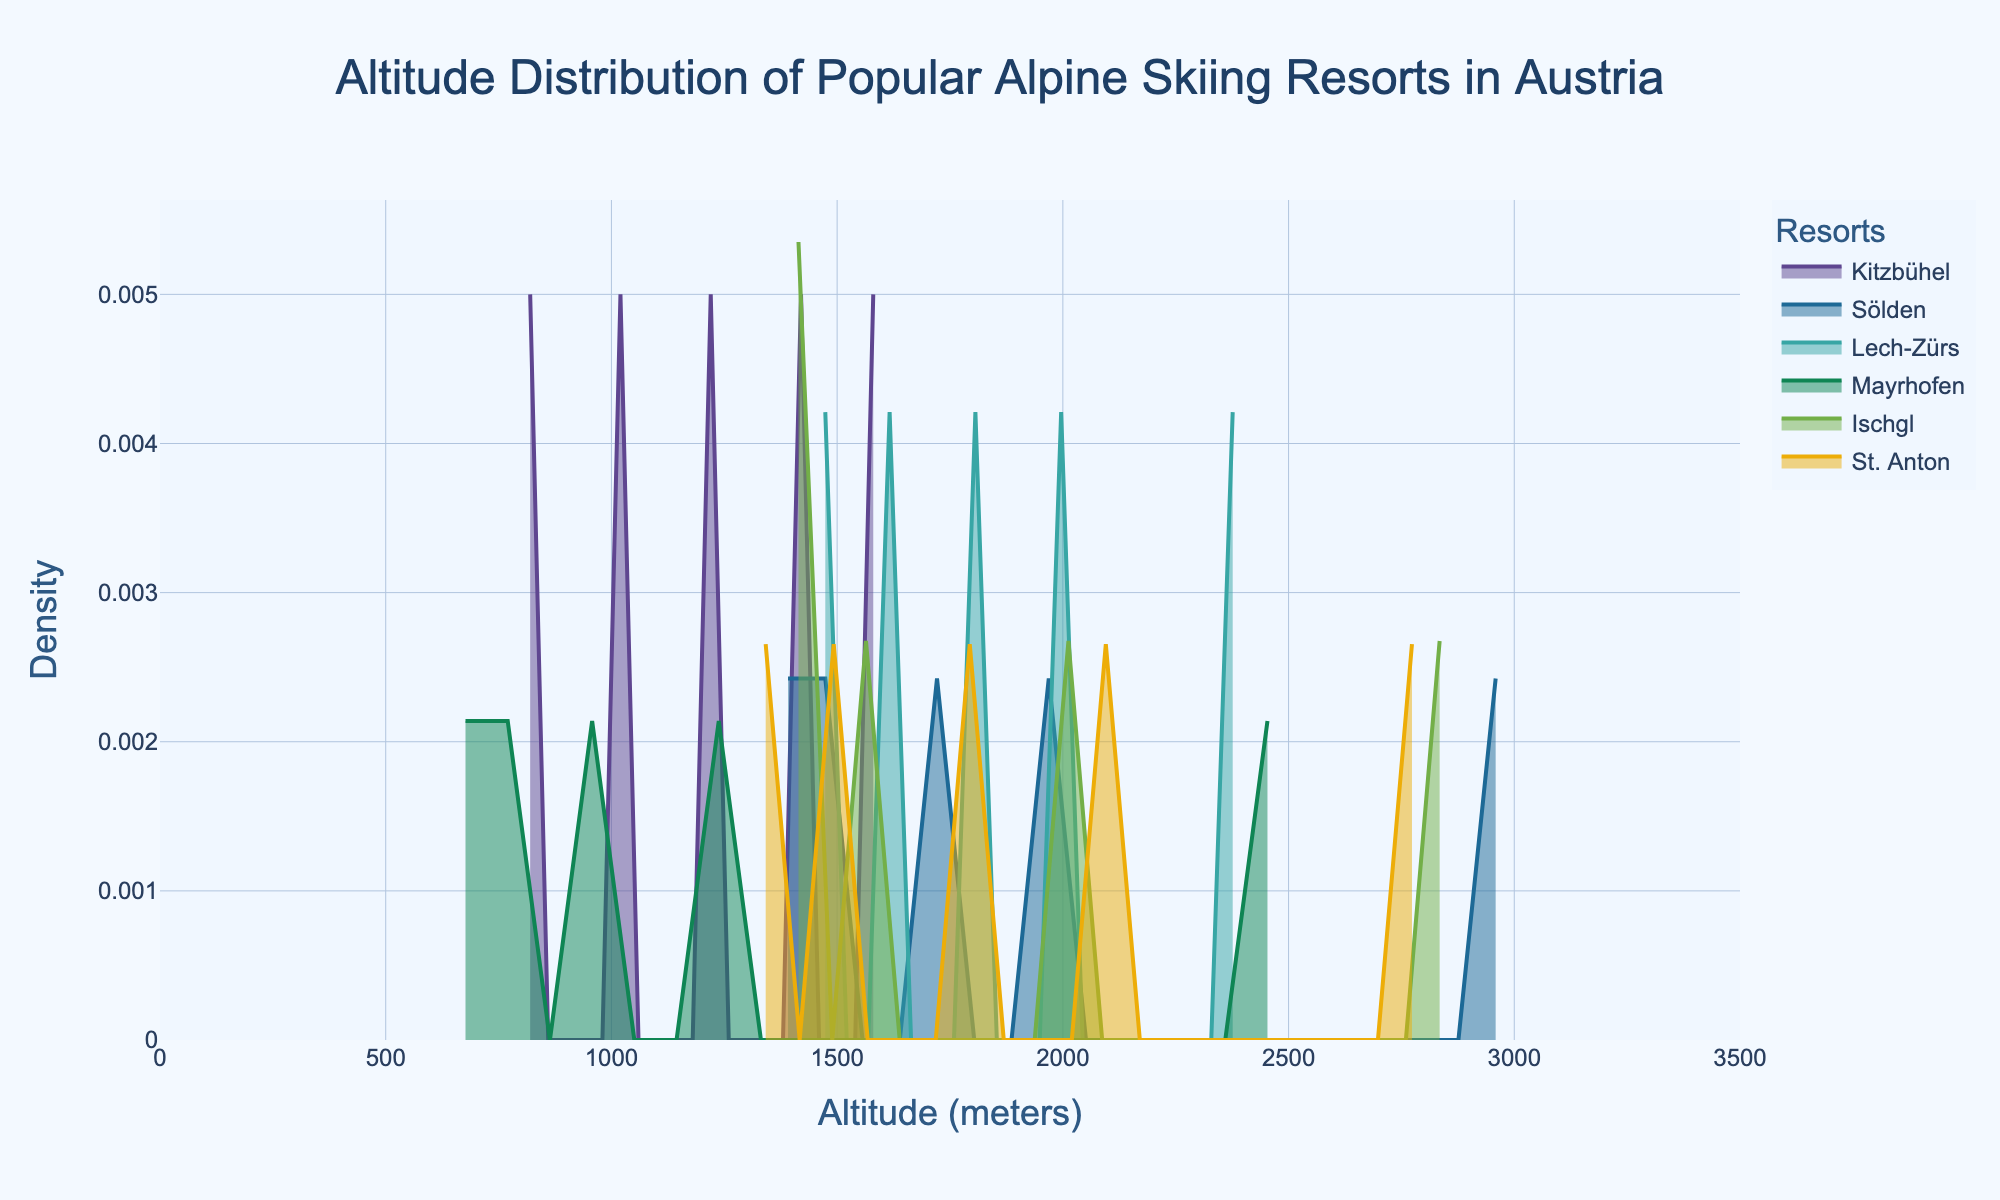What is the title of the figure? The title of the figure is found at the top and provides a summary of what the figure is about.
Answer: Altitude Distribution of Popular Alpine Skiing Resorts in Austria What is the average altitude for the Kitzbühel resort? To find the average, sum all the altitudes for Kitzbühel (800 + 1000 + 1200 + 1400 + 1600) and divide by the number of points (5). So, (800 + 1000 + 1200 + 1400 + 1600) / 5 = 6000 / 5.
Answer: 1200 Which resort has the highest peak density at high altitudes (above 2500 meters)? Review the left end of the curves on the plot, focusing on altitudes above 2500 meters. The highest density line in this region will indicate the resort with the highest peak density.
Answer: Sölden What is the altitude range for the Lech-Zürs resort shown in the figure? Identify the minimum and maximum altitudes for the Lech-Zürs resort data points.
Answer: 1450 to 2400 Which resort appears to have the widest range of altitudes? Compare the range of altitudes for each resort: subtract the minimum altitude from the maximum altitude for each resort. The resort with the largest result has the widest range.
Answer: Sölden How does the altitude distribution of Mayrhofen compare to that of Ischgl? Observe the area under the density curves for both Mayrhofen and Ischgl. Compare their shapes, spreads, and peak altitudes.
Answer: Mayrhofen has lower altitudes and a less spread-out distribution compared to Ischgl Between Kitzbühel and St. Anton, which resort has a higher density at around 2000 meters? Look at the density values around 2000 meters on the x-axis; compare the heights of the density curves for Kitzbühel and St. Anton.
Answer: St. Anton Which altitudes show overlapping density distributions for multiple resorts? Identify the regions on the x-axis where the density curves of multiple resorts overlap.
Answer: 1400-1600 and 2000-2100 